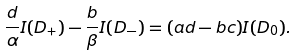<formula> <loc_0><loc_0><loc_500><loc_500>\frac { d } { \alpha } I ( D _ { + } ) - \frac { b } { \beta } I ( D _ { - } ) = ( a d - b c ) I ( D _ { 0 } ) .</formula> 